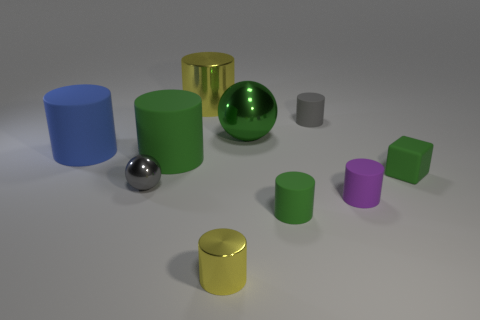What is the shape of the gray thing on the right side of the small object to the left of the large metallic thing behind the big green shiny sphere?
Offer a terse response. Cylinder. What is the shape of the yellow metallic thing behind the small purple matte cylinder?
Offer a very short reply. Cylinder. Does the big blue cylinder have the same material as the tiny object left of the large green cylinder?
Your answer should be very brief. No. What number of other objects are there of the same shape as the blue rubber object?
Offer a very short reply. 6. There is a rubber block; is its color the same as the tiny matte object that is left of the gray matte cylinder?
Offer a very short reply. Yes. There is a large rubber object that is to the right of the big matte object that is to the left of the gray metal ball; what shape is it?
Your answer should be compact. Cylinder. What size is the other cylinder that is the same color as the big metallic cylinder?
Your response must be concise. Small. There is a small gray object that is behind the large green shiny object; does it have the same shape as the big blue matte object?
Ensure brevity in your answer.  Yes. Are there more rubber cylinders on the right side of the large blue rubber cylinder than green things that are behind the tiny green rubber cube?
Provide a short and direct response. Yes. There is a yellow metal cylinder that is behind the tiny gray matte thing; how many matte things are in front of it?
Provide a short and direct response. 6. 